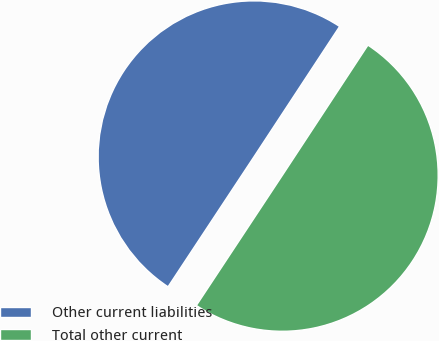Convert chart. <chart><loc_0><loc_0><loc_500><loc_500><pie_chart><fcel>Other current liabilities<fcel>Total other current<nl><fcel>49.96%<fcel>50.04%<nl></chart> 